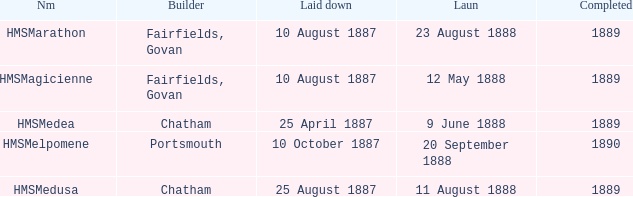When did chatham complete the Hmsmedusa? 1889.0. 